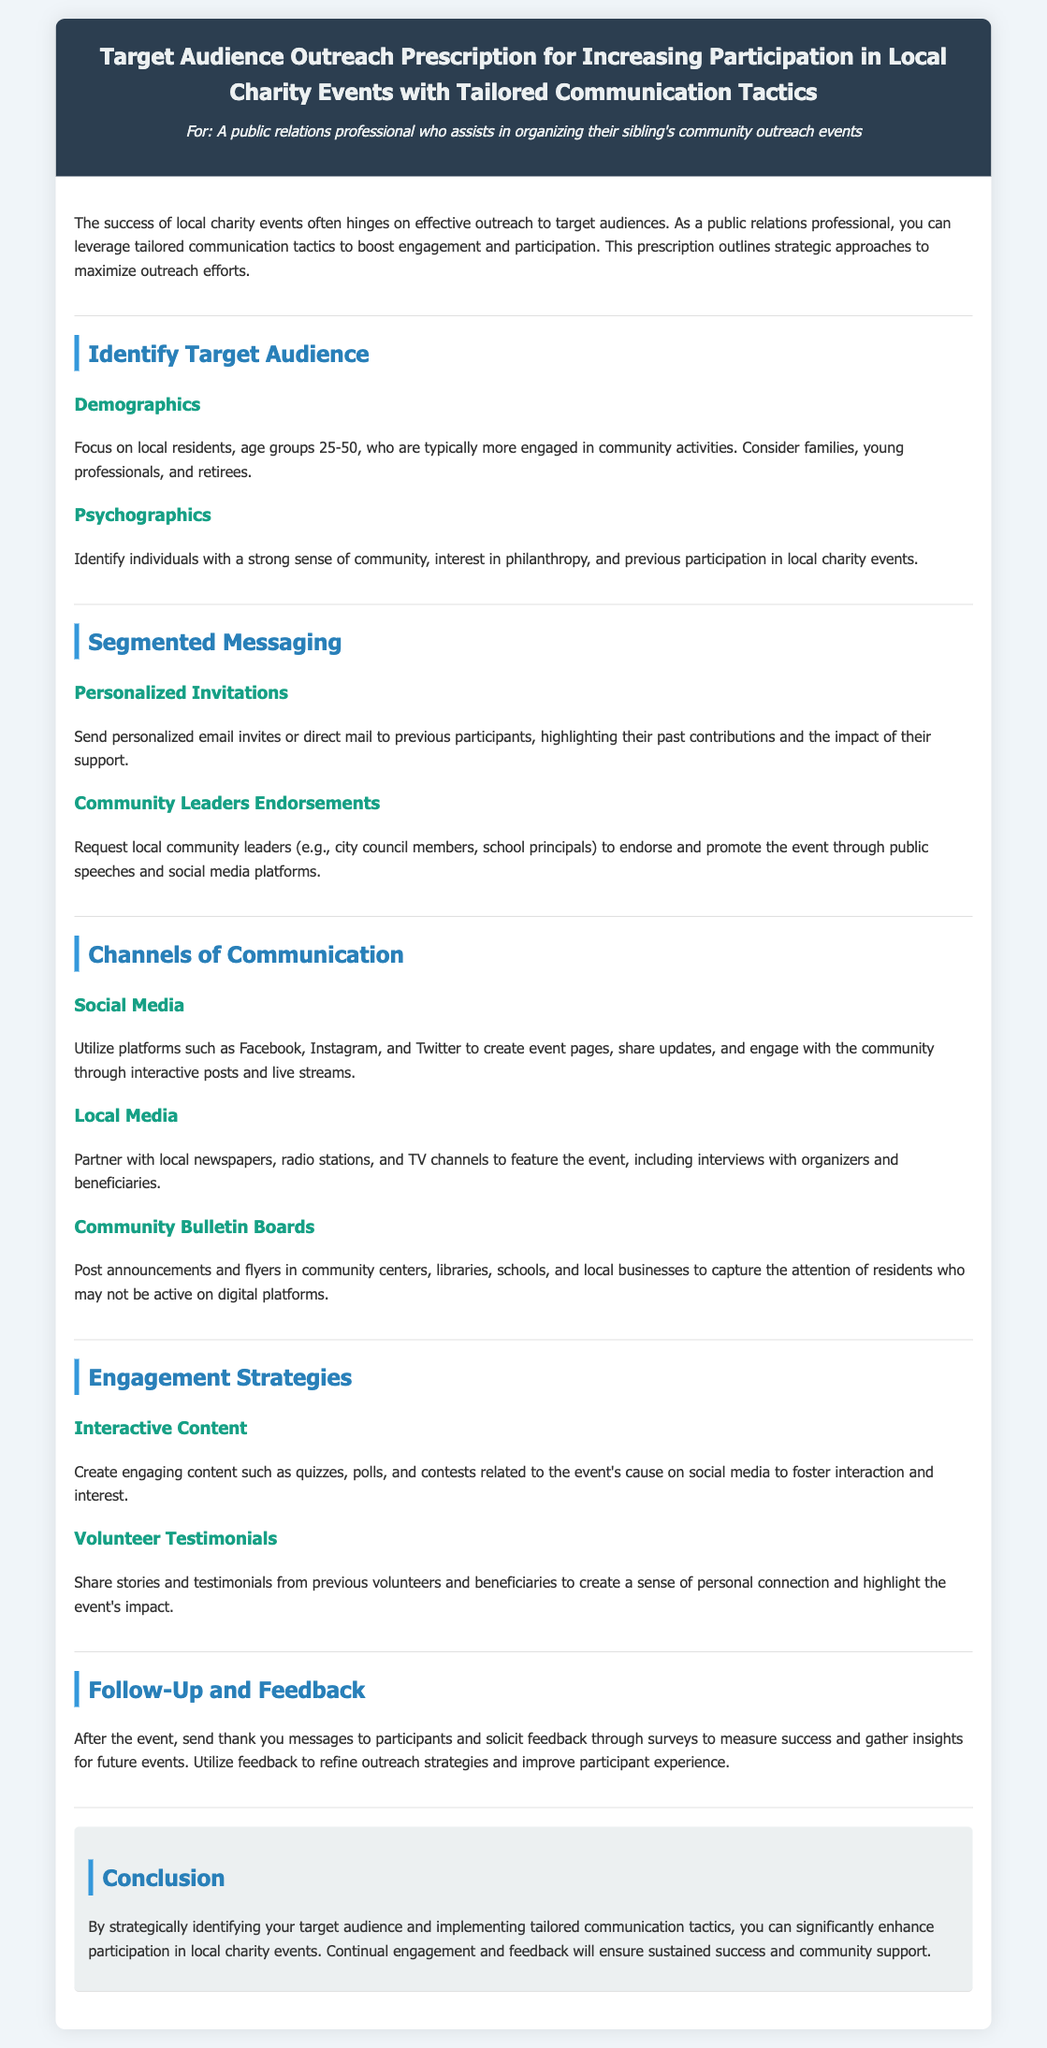What is the target age group for the outreach? The document specifies focusing on local residents, age groups 25-50.
Answer: 25-50 Which community members are suggested for endorsements? The document mentions requesting endorsements from local community leaders like city council members and school principals.
Answer: Community leaders What social media platforms are recommended for communication? The document lists Facebook, Instagram, and Twitter as platforms to utilize for creating event pages.
Answer: Facebook, Instagram, Twitter What type of content is suggested to engage the audience on social media? The document recommends creating quizzes, polls, and contests related to the event's cause.
Answer: Interactive content What should be sent to participants after the event? The document advises sending thank you messages and soliciting feedback.
Answer: Thank you messages How can previous participants be targeted? Personal invitations highlighting their past contributions should be sent to engage previous participants.
Answer: Personalized invitations What type of media partnerships does the document suggest? Partnering with local newspapers, radio stations, and TV channels is suggested to feature the event.
Answer: Local media Which section discusses the importance of personal connection? The section on "Volunteer Testimonials" highlights the importance of sharing stories to create personal connections.
Answer: Volunteer Testimonials 